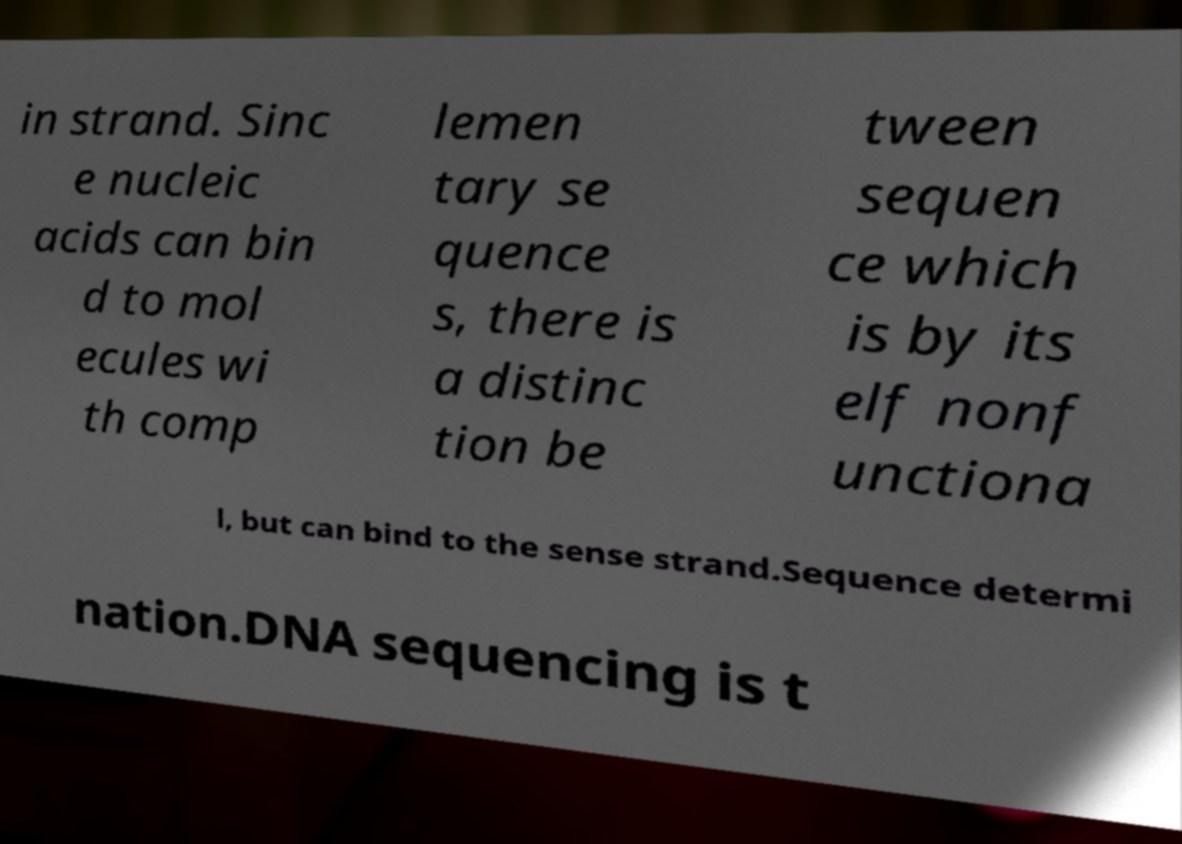Please read and relay the text visible in this image. What does it say? in strand. Sinc e nucleic acids can bin d to mol ecules wi th comp lemen tary se quence s, there is a distinc tion be tween sequen ce which is by its elf nonf unctiona l, but can bind to the sense strand.Sequence determi nation.DNA sequencing is t 